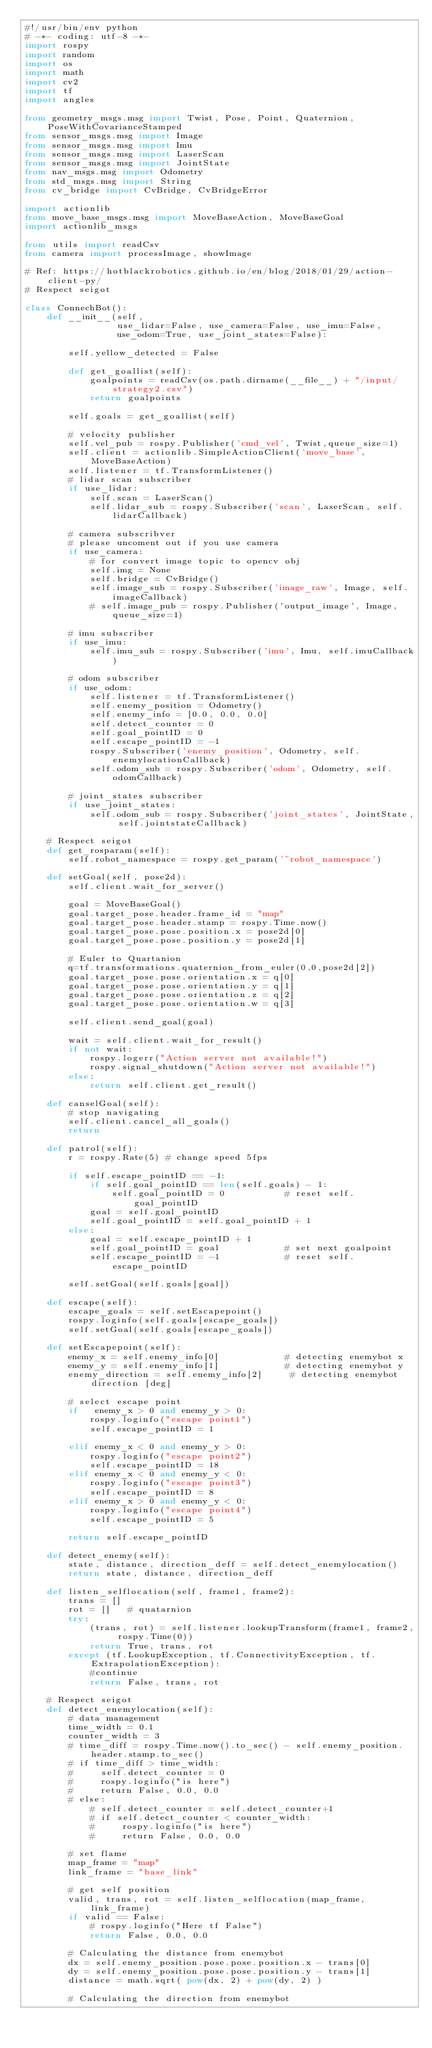Convert code to text. <code><loc_0><loc_0><loc_500><loc_500><_Python_>#!/usr/bin/env python
# -*- coding: utf-8 -*-
import rospy
import random
import os
import math
import cv2
import tf
import angles

from geometry_msgs.msg import Twist, Pose, Point, Quaternion, PoseWithCovarianceStamped
from sensor_msgs.msg import Image
from sensor_msgs.msg import Imu
from sensor_msgs.msg import LaserScan
from sensor_msgs.msg import JointState
from nav_msgs.msg import Odometry
from std_msgs.msg import String
from cv_bridge import CvBridge, CvBridgeError

import actionlib
from move_base_msgs.msg import MoveBaseAction, MoveBaseGoal
import actionlib_msgs

from utils import readCsv
from camera import processImage, showImage

# Ref: https://hotblackrobotics.github.io/en/blog/2018/01/29/action-client-py/
# Respect seigot

class ConnechBot():
    def __init__(self, 
                 use_lidar=False, use_camera=False, use_imu=False,
                 use_odom=True, use_joint_states=False):

        self.yellow_detected = False

        def get_goallist(self):
            goalpoints = readCsv(os.path.dirname(__file__) + "/input/strategy2.csv")
            return goalpoints
        
        self.goals = get_goallist(self)

        # velocity publisher
        self.vel_pub = rospy.Publisher('cmd_vel', Twist,queue_size=1)
        self.client = actionlib.SimpleActionClient('move_base',MoveBaseAction)
        self.listener = tf.TransformListener()
        # lidar scan subscriber
        if use_lidar:
            self.scan = LaserScan()
            self.lidar_sub = rospy.Subscriber('scan', LaserScan, self.lidarCallback)

        # camera subscribver
        # please uncoment out if you use camera
        if use_camera:
            # for convert image topic to opencv obj
            self.img = None
            self.bridge = CvBridge()
            self.image_sub = rospy.Subscriber('image_raw', Image, self.imageCallback)
            # self.image_pub = rospy.Publisher('output_image', Image, queue_size=1)

        # imu subscriber
        if use_imu:
            self.imu_sub = rospy.Subscriber('imu', Imu, self.imuCallback)

        # odom subscriber
        if use_odom:
            self.listener = tf.TransformListener()
            self.enemy_position = Odometry()
            self.enemy_info = [0.0, 0.0, 0.0]
            self.detect_counter = 0
            self.goal_pointID = 0
            self.escape_pointID = -1
            rospy.Subscriber('enemy_position', Odometry, self.enemylocationCallback)
            self.odom_sub = rospy.Subscriber('odom', Odometry, self.odomCallback)

        # joint_states subscriber
        if use_joint_states:
            self.odom_sub = rospy.Subscriber('joint_states', JointState, self.jointstateCallback)
            
    # Respect seigot
    def get_rosparam(self):
        self.robot_namespace = rospy.get_param('~robot_namespace')

    def setGoal(self, pose2d):
        self.client.wait_for_server()

        goal = MoveBaseGoal()
        goal.target_pose.header.frame_id = "map"
        goal.target_pose.header.stamp = rospy.Time.now()
        goal.target_pose.pose.position.x = pose2d[0]
        goal.target_pose.pose.position.y = pose2d[1]

        # Euler to Quartanion
        q=tf.transformations.quaternion_from_euler(0,0,pose2d[2])
        goal.target_pose.pose.orientation.x = q[0]
        goal.target_pose.pose.orientation.y = q[1]
        goal.target_pose.pose.orientation.z = q[2]
        goal.target_pose.pose.orientation.w = q[3]

        self.client.send_goal(goal)

        wait = self.client.wait_for_result()
        if not wait:
            rospy.logerr("Action server not available!")
            rospy.signal_shutdown("Action server not available!")
        else:
            return self.client.get_result() 

    def canselGoal(self):
        # stop navigating
        self.client.cancel_all_goals()
        return
    
    def patrol(self):
        r = rospy.Rate(5) # change speed 5fps

        if self.escape_pointID == -1:
            if self.goal_pointID == len(self.goals) - 1:     
                self.goal_pointID = 0           # reset self.goal_pointID
            goal = self.goal_pointID
            self.goal_pointID = self.goal_pointID + 1
        else:
            goal = self.escape_pointID + 1
            self.goal_pointID = goal            # set next goalpoint
            self.escape_pointID = -1            # reset self.escape_pointID

        self.setGoal(self.goals[goal])

    def escape(self):
        escape_goals = self.setEscapepoint()
        rospy.loginfo(self.goals[escape_goals])
        self.setGoal(self.goals[escape_goals])

    def setEscapepoint(self):
        enemy_x = self.enemy_info[0]            # detecting enemybot x
        enemy_y = self.enemy_info[1]            # detecting enemybot y
        enemy_direction = self.enemy_info[2]     # detecting enemybot direction [deg]
        
        # select escape point
        if   enemy_x > 0 and enemy_y > 0: 
            rospy.loginfo("escape point1")
            self.escape_pointID = 1

        elif enemy_x < 0 and enemy_y > 0:
            rospy.loginfo("escape point2")
            self.escape_pointID = 18
        elif enemy_x < 0 and enemy_y < 0:
            rospy.loginfo("escape point3")
            self.escape_pointID = 8
        elif enemy_x > 0 and enemy_y < 0:
            rospy.loginfo("escape point4")
            self.escape_pointID = 5
        
        return self.escape_pointID

    def detect_enemy(self):
        state, distance, direction_deff = self.detect_enemylocation()
        return state, distance, direction_deff

    def listen_selflocation(self, frame1, frame2):
        trans = []
        rot = []   # quatarnion
        try:
            (trans, rot) = self.listener.lookupTransform(frame1, frame2, rospy.Time(0))
            return True, trans, rot
        except (tf.LookupException, tf.ConnectivityException, tf.ExtrapolationException):
            #continue
            return False, trans, rot

    # Respect seigot
    def detect_enemylocation(self):
        # data management
        time_width = 0.1
        counter_width = 3
        # time_diff = rospy.Time.now().to_sec() - self.enemy_position.header.stamp.to_sec()
        # if time_diff > time_width:
        #     self.detect_counter = 0
        #     rospy.loginfo("is here")
        #     return False, 0.0, 0.0
        # else:
            # self.detect_counter = self.detect_counter+1
            # if self.detect_counter < counter_width:
            #     rospy.loginfo("is here")
            #     return False, 0.0, 0.0

        # set flame
        map_frame = "map"
        link_frame = "base_link"
        
        # get self position
        valid, trans, rot = self.listen_selflocation(map_frame, link_frame)
        if valid == False:
            # rospy.loginfo("Here tf False")
            return False, 0.0, 0.0

        # Calculating the distance from enemybot 
        dx = self.enemy_position.pose.pose.position.x - trans[0]
        dy = self.enemy_position.pose.pose.position.y - trans[1]
        distance = math.sqrt( pow(dx, 2) + pow(dy, 2) )
        
        # Calculating the direction from enemybot</code> 